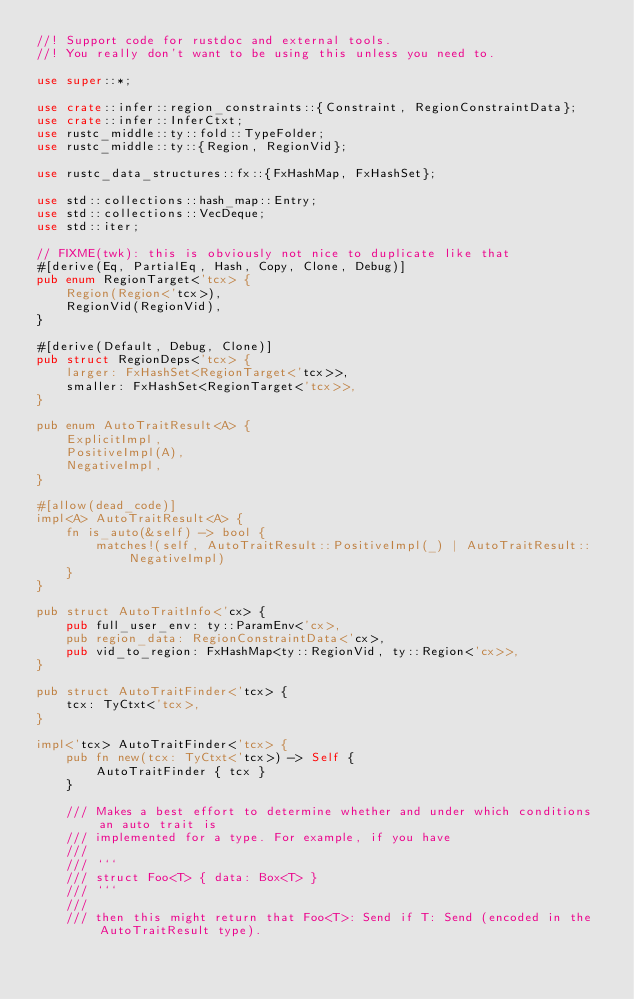Convert code to text. <code><loc_0><loc_0><loc_500><loc_500><_Rust_>//! Support code for rustdoc and external tools.
//! You really don't want to be using this unless you need to.

use super::*;

use crate::infer::region_constraints::{Constraint, RegionConstraintData};
use crate::infer::InferCtxt;
use rustc_middle::ty::fold::TypeFolder;
use rustc_middle::ty::{Region, RegionVid};

use rustc_data_structures::fx::{FxHashMap, FxHashSet};

use std::collections::hash_map::Entry;
use std::collections::VecDeque;
use std::iter;

// FIXME(twk): this is obviously not nice to duplicate like that
#[derive(Eq, PartialEq, Hash, Copy, Clone, Debug)]
pub enum RegionTarget<'tcx> {
    Region(Region<'tcx>),
    RegionVid(RegionVid),
}

#[derive(Default, Debug, Clone)]
pub struct RegionDeps<'tcx> {
    larger: FxHashSet<RegionTarget<'tcx>>,
    smaller: FxHashSet<RegionTarget<'tcx>>,
}

pub enum AutoTraitResult<A> {
    ExplicitImpl,
    PositiveImpl(A),
    NegativeImpl,
}

#[allow(dead_code)]
impl<A> AutoTraitResult<A> {
    fn is_auto(&self) -> bool {
        matches!(self, AutoTraitResult::PositiveImpl(_) | AutoTraitResult::NegativeImpl)
    }
}

pub struct AutoTraitInfo<'cx> {
    pub full_user_env: ty::ParamEnv<'cx>,
    pub region_data: RegionConstraintData<'cx>,
    pub vid_to_region: FxHashMap<ty::RegionVid, ty::Region<'cx>>,
}

pub struct AutoTraitFinder<'tcx> {
    tcx: TyCtxt<'tcx>,
}

impl<'tcx> AutoTraitFinder<'tcx> {
    pub fn new(tcx: TyCtxt<'tcx>) -> Self {
        AutoTraitFinder { tcx }
    }

    /// Makes a best effort to determine whether and under which conditions an auto trait is
    /// implemented for a type. For example, if you have
    ///
    /// ```
    /// struct Foo<T> { data: Box<T> }
    /// ```
    ///
    /// then this might return that Foo<T>: Send if T: Send (encoded in the AutoTraitResult type).</code> 